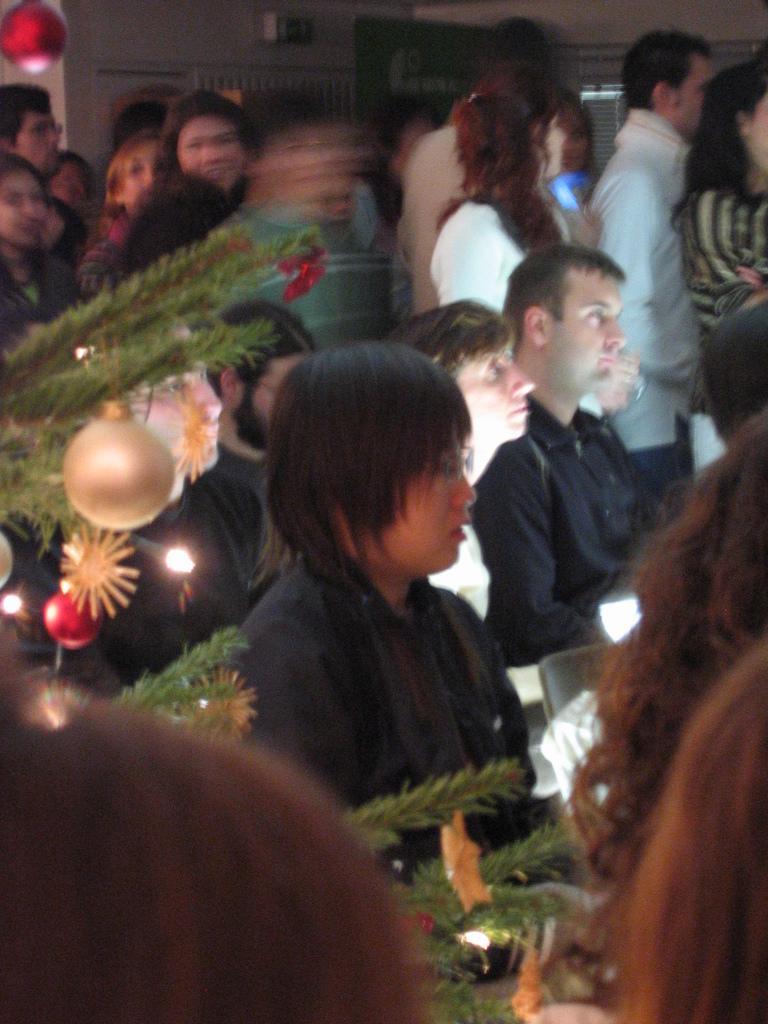In one or two sentences, can you explain what this image depicts? In the center of the image we can see a few people are sitting and a few people are standing. And we can see a part of the Xmas tree with some decorative items on it. In the background, we can see some objects. 